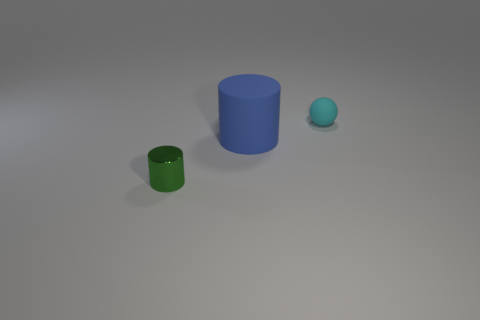Does the blue thing have the same size as the sphere?
Give a very brief answer. No. What is the shape of the large thing that is made of the same material as the cyan sphere?
Provide a succinct answer. Cylinder. How many other objects are the same shape as the cyan object?
Ensure brevity in your answer.  0. There is a matte thing that is to the right of the cylinder that is right of the small object left of the cyan rubber object; what is its shape?
Your answer should be very brief. Sphere. How many blocks are tiny metallic things or cyan things?
Provide a succinct answer. 0. There is a cylinder behind the small green metal cylinder; is there a small cyan object right of it?
Offer a terse response. Yes. Is there anything else that is the same material as the small green object?
Keep it short and to the point. No. Is the shape of the big thing the same as the small thing to the left of the cyan sphere?
Offer a very short reply. Yes. How many other things are there of the same size as the matte cylinder?
Offer a terse response. 0. What number of yellow things are big rubber cylinders or large cubes?
Your answer should be very brief. 0. 